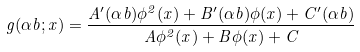<formula> <loc_0><loc_0><loc_500><loc_500>g ( \alpha b ; x ) = \frac { A ^ { \prime } ( \alpha b ) \phi ^ { 2 } ( x ) + B ^ { \prime } ( \alpha b ) \phi ( x ) + C ^ { \prime } ( \alpha b ) } { A \phi ^ { 2 } ( x ) + B \phi ( x ) + C }</formula> 